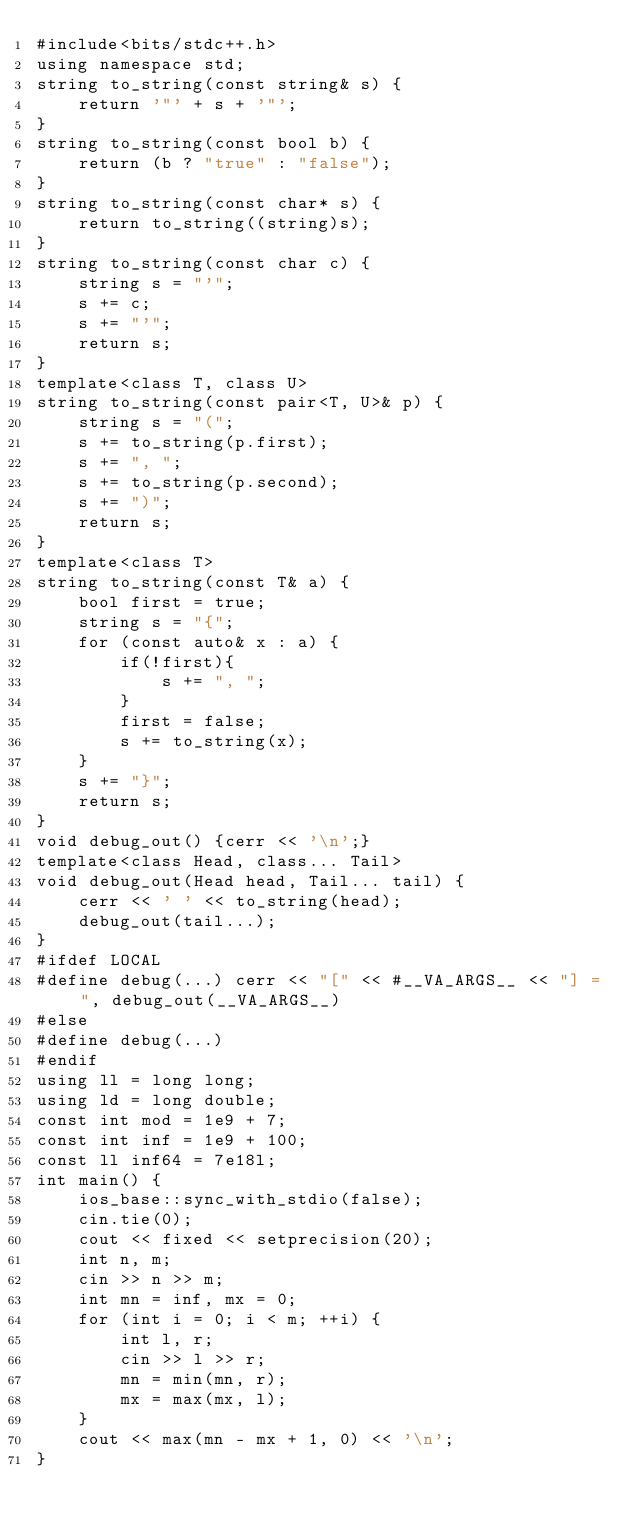<code> <loc_0><loc_0><loc_500><loc_500><_C++_>#include<bits/stdc++.h>
using namespace std;
string to_string(const string& s) {
	return '"' + s + '"';
}
string to_string(const bool b) {
	return (b ? "true" : "false");
}
string to_string(const char* s) {
	return to_string((string)s);
}
string to_string(const char c) {
	string s = "'";
	s += c;
	s += "'";
	return s;
}
template<class T, class U>
string to_string(const pair<T, U>& p) {
	string s = "(";
	s += to_string(p.first);
	s += ", ";
	s += to_string(p.second);
	s += ")";
	return s;
}
template<class T>
string to_string(const T& a) {
	bool first = true;
	string s = "{";
	for (const auto& x : a) {
		if(!first){
			s += ", ";
		}
		first = false;
		s += to_string(x);
	}
	s += "}";
	return s;
}
void debug_out() {cerr << '\n';}
template<class Head, class... Tail>
void debug_out(Head head, Tail... tail) {
	cerr << ' ' << to_string(head);
	debug_out(tail...);
}
#ifdef LOCAL
#define debug(...) cerr << "[" << #__VA_ARGS__ << "] = ", debug_out(__VA_ARGS__)
#else
#define debug(...)
#endif
using ll = long long;
using ld = long double;
const int mod = 1e9 + 7;
const int inf = 1e9 + 100;
const ll inf64 = 7e18l;
int main() {
	ios_base::sync_with_stdio(false);
	cin.tie(0);
	cout << fixed << setprecision(20);
	int n, m;
	cin >> n >> m;
	int mn = inf, mx = 0;
	for (int i = 0; i < m; ++i) {
		int l, r;
		cin >> l >> r;
		mn = min(mn, r);
		mx = max(mx, l);
	}
	cout << max(mn - mx + 1, 0) << '\n';
}
</code> 